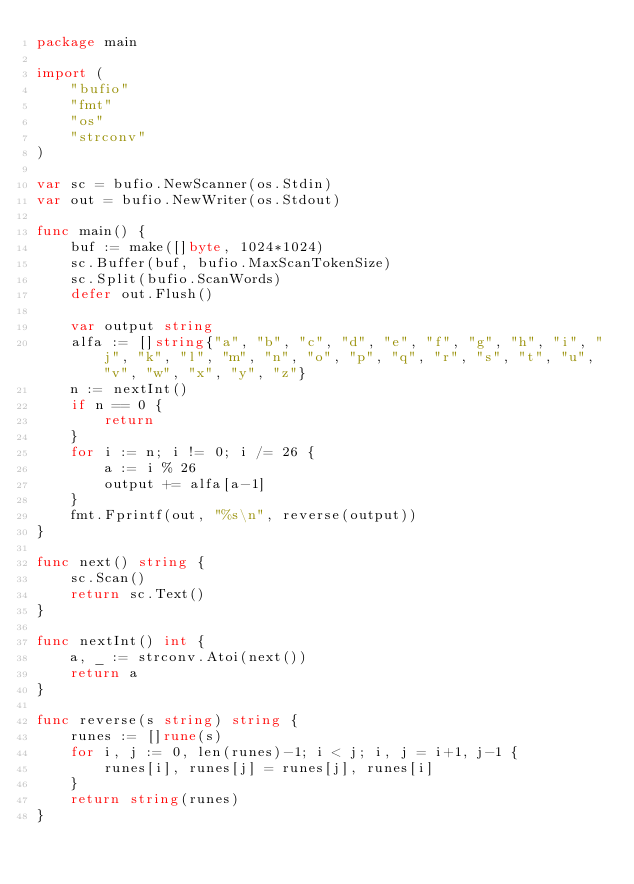Convert code to text. <code><loc_0><loc_0><loc_500><loc_500><_Go_>package main

import (
	"bufio"
	"fmt"
	"os"
	"strconv"
)

var sc = bufio.NewScanner(os.Stdin)
var out = bufio.NewWriter(os.Stdout)

func main() {
	buf := make([]byte, 1024*1024)
	sc.Buffer(buf, bufio.MaxScanTokenSize)
	sc.Split(bufio.ScanWords)
	defer out.Flush()

	var output string
	alfa := []string{"a", "b", "c", "d", "e", "f", "g", "h", "i", "j", "k", "l", "m", "n", "o", "p", "q", "r", "s", "t", "u", "v", "w", "x", "y", "z"}
	n := nextInt()
	if n == 0 {
		return
	}
	for i := n; i != 0; i /= 26 {
		a := i % 26
		output += alfa[a-1]
	}
	fmt.Fprintf(out, "%s\n", reverse(output))
}

func next() string {
	sc.Scan()
	return sc.Text()
}

func nextInt() int {
	a, _ := strconv.Atoi(next())
	return a
}

func reverse(s string) string {
	runes := []rune(s)
	for i, j := 0, len(runes)-1; i < j; i, j = i+1, j-1 {
		runes[i], runes[j] = runes[j], runes[i]
	}
	return string(runes)
}
</code> 